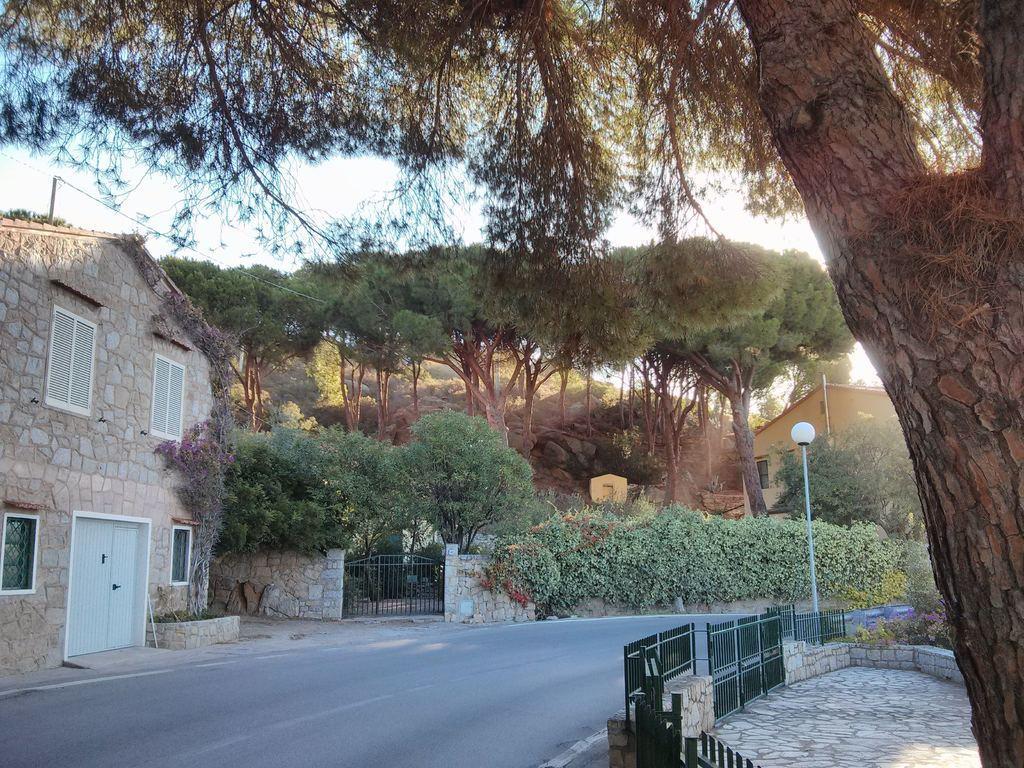Describe this image in one or two sentences. In this image I can see a building and windows. I can see a black color gate and fencing. Back I can see pole and trees. The sky is in white color. We can see white color door. 